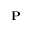Convert formula to latex. <formula><loc_0><loc_0><loc_500><loc_500>{ P }</formula> 